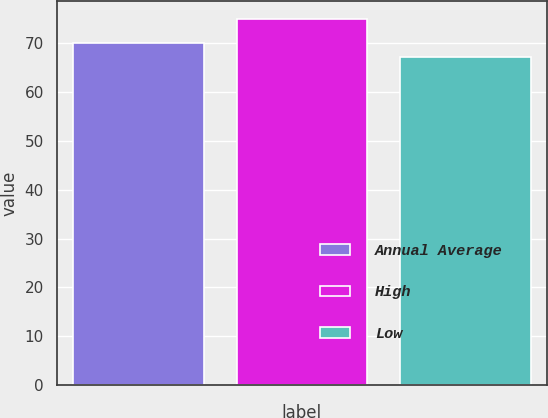Convert chart. <chart><loc_0><loc_0><loc_500><loc_500><bar_chart><fcel>Annual Average<fcel>High<fcel>Low<nl><fcel>70<fcel>74.9<fcel>67.1<nl></chart> 